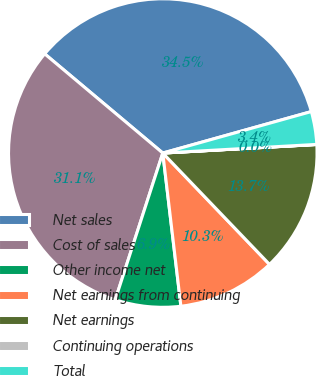Convert chart. <chart><loc_0><loc_0><loc_500><loc_500><pie_chart><fcel>Net sales<fcel>Cost of sales<fcel>Other income net<fcel>Net earnings from continuing<fcel>Net earnings<fcel>Continuing operations<fcel>Total<nl><fcel>34.55%<fcel>31.13%<fcel>6.86%<fcel>10.29%<fcel>13.72%<fcel>0.01%<fcel>3.44%<nl></chart> 